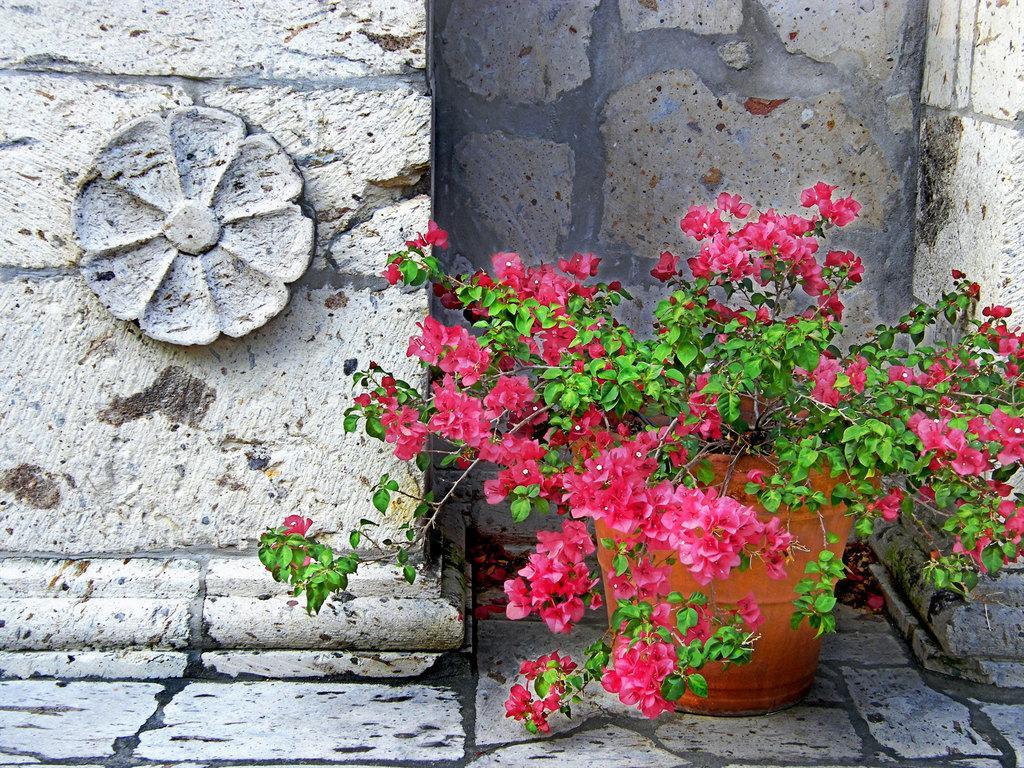Could you give a brief overview of what you see in this image? In this image we can see pink color flowers of the plant and flower pot. Here we can see flower design to the stone wall in the background. 